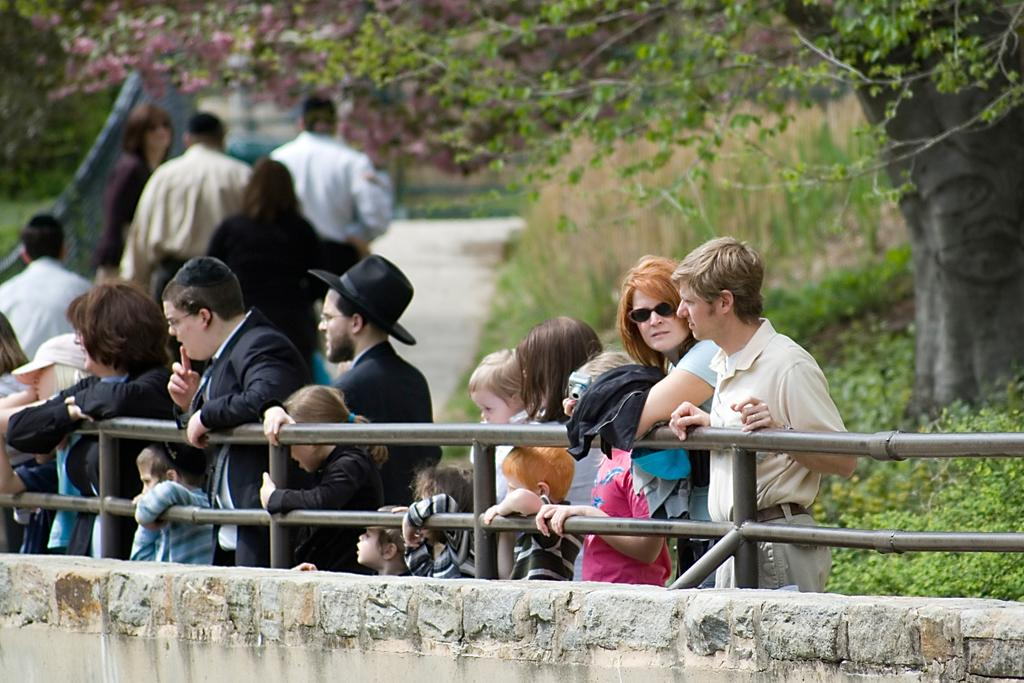What are the people in the image doing? The people in the image are standing and holding a metal railing. What is the metal railing attached to? The metal railing is attached to a wall. What can be seen in the background of the image? There are trees and plants in the background of the image. What type of balls are being used to cover the lumber in the image? There are no balls or lumber present in the image; it features people holding a metal railing attached to a wall, with trees and plants in the background. 